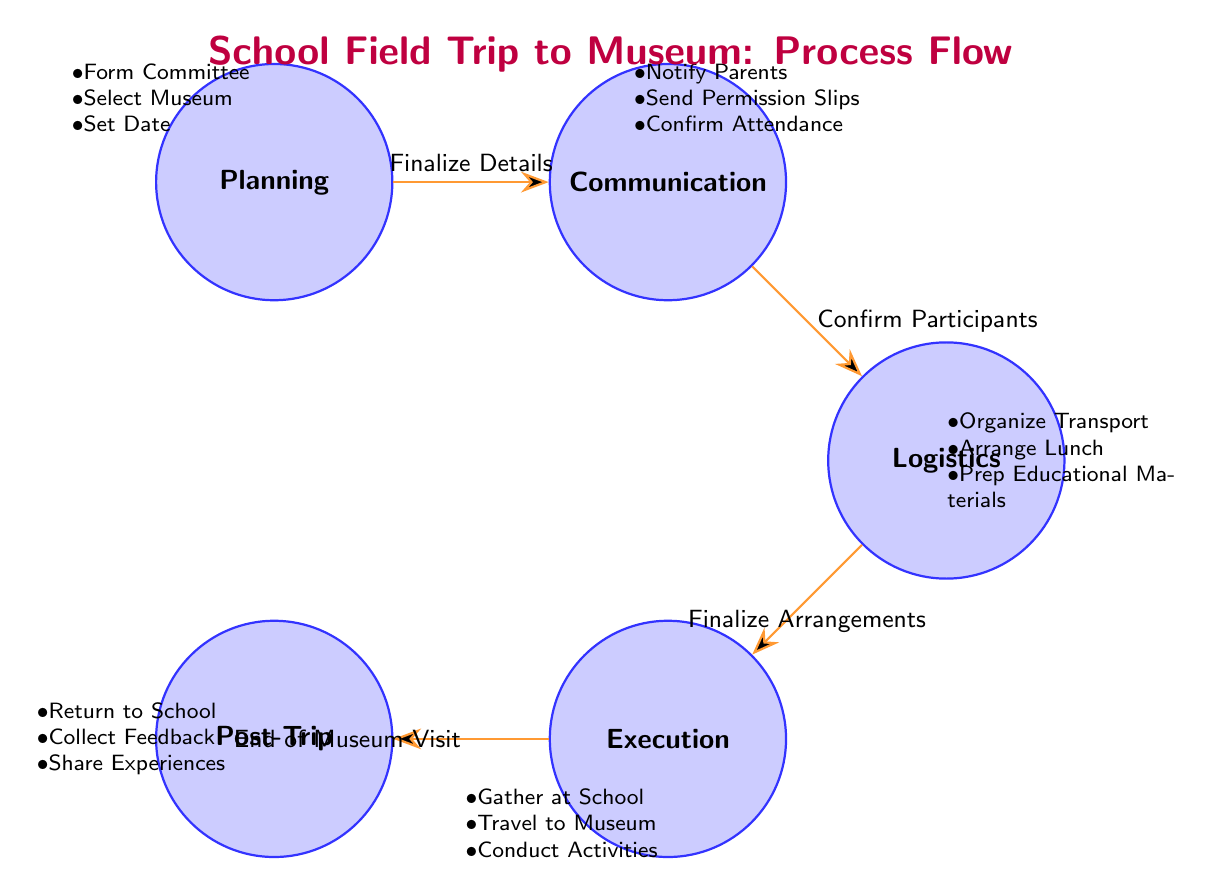What is the first state in the diagram? The first state in the diagram is labeled as "Planning". It is located at the top left position among the states, indicating the initial phase of organizing the school field trip.
Answer: Planning How many actions are listed under the "Logistics" state? The "Logistics" state contains three specific actions: "Organize Transport", "Arrange Lunch", and "Prep Educational Materials". By counting these actions, we find there are three.
Answer: 3 What is the last action before transitioning to the "Post-Trip" state? The last action that leads to the "Post-Trip" state is "End of Museum Visit". It is the transition that connects the "Execution" state to the "Post-Trip" state, indicating the conclusion of the visit.
Answer: End of Museum Visit Which state follows the "Communication" state? The state that follows the "Communication" state is "Logistics". This transition happens after the action of confirming participants, allowing movement to the logistical arrangements required for the field trip.
Answer: Logistics How many total states are represented in the diagram? The diagram illustrates a total of five distinct states: "Planning", "Communication", "Logistics", "Execution", and "Post-Trip". This provides a complete flow of how the field trip is organized.
Answer: 5 What action occurs between the "Logistics" and "Execution" states? The action that occurs between the "Logistics" and "Execution" states is "Finalize Arrangements". This step is critical for ensuring that everything is set before the trip proceeds to execution.
Answer: Finalize Arrangements Which state includes the action "Send Permission Slips"? The action "Send Permission Slips" is included in the "Communication" state. It is one of the essential actions to ensure that parents are informed and give their consent for their children to participate in the museum visit.
Answer: Communication What connects the "Planning" state to the "Communication" state? The connection between the "Planning" state and the "Communication" state is made through the action "Finalize Details". This action signifies that the planning has been completed and communication can now take place.
Answer: Finalize Details What is a key task performed in the "Execution" state? A key task performed in the "Execution" state is "Conduct Activities". This is an essential part of the field trip, where the students engage in educational activities at the museum.
Answer: Conduct Activities 